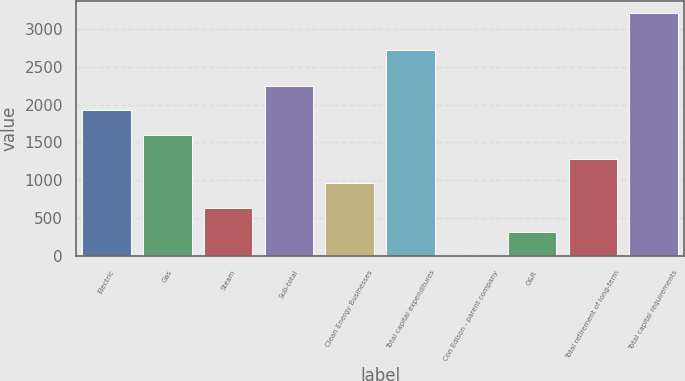<chart> <loc_0><loc_0><loc_500><loc_500><bar_chart><fcel>Electric<fcel>Gas<fcel>Steam<fcel>Sub-total<fcel>Clean Energy Businesses<fcel>Total capital expenditures<fcel>Con Edison - parent company<fcel>O&R<fcel>Total retirement of long-term<fcel>Total capital requirements<nl><fcel>1924.4<fcel>1604<fcel>642.8<fcel>2244.8<fcel>963.2<fcel>2721<fcel>2<fcel>322.4<fcel>1283.6<fcel>3206<nl></chart> 